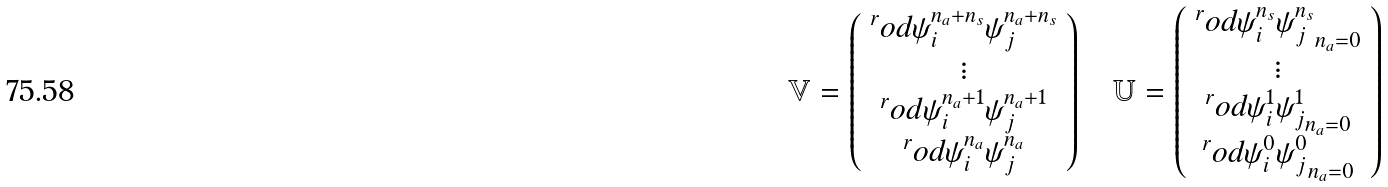Convert formula to latex. <formula><loc_0><loc_0><loc_500><loc_500>\mathbb { V } = \left ( \begin{array} { c } ^ { r } o d { \psi _ { i } ^ { n _ { a } + n _ { s } } } { \psi _ { j } ^ { n _ { a } + n _ { s } } } \\ \vdots \\ ^ { r } o d { \psi _ { i } ^ { n _ { a } + 1 } } { \psi _ { j } ^ { n _ { a } + 1 } } \\ ^ { r } o d { \psi _ { i } ^ { n _ { a } } } { \psi _ { j } ^ { n _ { a } } } \end{array} \right ) \quad \mathbb { U } = \left ( \begin{array} { c } ^ { r } o d { \psi _ { i } ^ { n _ { s } } } { \psi _ { j } ^ { n _ { s } } } _ { n _ { a } = 0 } \\ \vdots \\ ^ { r } o d { \psi _ { i } ^ { 1 } } { \psi _ { j } ^ { 1 } } _ { n _ { a } = 0 } \\ ^ { r } o d { \psi _ { i } ^ { 0 } } { \psi _ { j } ^ { 0 } } _ { n _ { a } = 0 } \end{array} \right )</formula> 